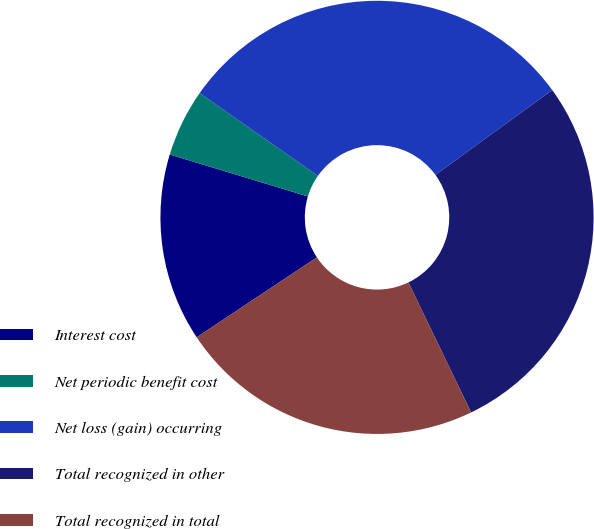<chart> <loc_0><loc_0><loc_500><loc_500><pie_chart><fcel>Interest cost<fcel>Net periodic benefit cost<fcel>Net loss (gain) occurring<fcel>Total recognized in other<fcel>Total recognized in total<nl><fcel>14.03%<fcel>5.04%<fcel>30.27%<fcel>27.85%<fcel>22.81%<nl></chart> 